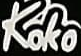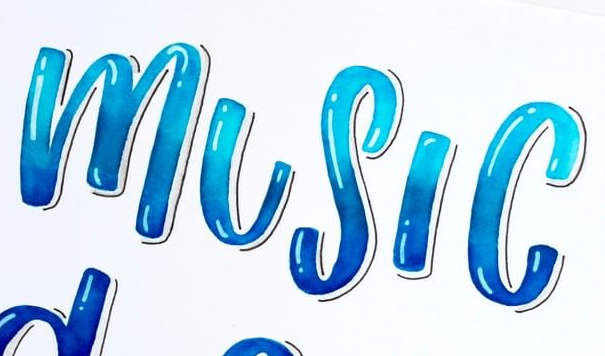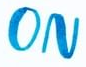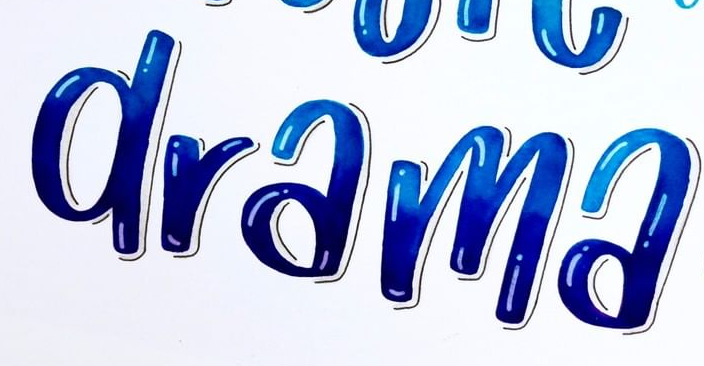What text appears in these images from left to right, separated by a semicolon? Koko; MUSIC; ON; drama 